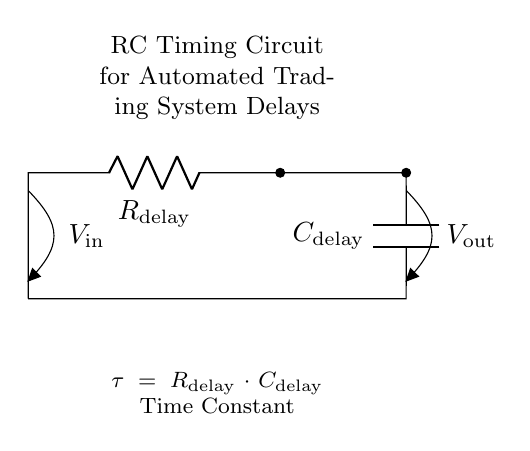What is the type of this circuit? The circuit is an RC timing circuit, as indicated by the presence of a resistor and a capacitor in series, used to create a specific time delay.
Answer: RC timing circuit What do R and C represent in this circuit? R represents the resistance value, specifically labeled as R delay, and C represents the capacitance value, specifically labeled as C delay.
Answer: R delay and C delay What is the formula for the time constant in this circuit? The time constant is given by the product of resistance and capacitance, expressed as tau equals R delay multiplied by C delay.
Answer: tau equals R delay multiplied by C delay What are the output and input voltages labeled as? The input voltage is labeled V in, and the output voltage is labeled V out. This shows the points where the voltages are measured in the circuit.
Answer: V in and V out How does increasing R delay affect the time constant? Increasing R delay increases the time constant, since tau is directly proportional to R delay, meaning the circuit will take longer to charge or discharge.
Answer: Increases time constant What happens to V out when the circuit reaches its time constant? At the time constant, V out will reach approximately 63.2% of V in, demonstrating how the capacitor charges over time in relation to the input voltage.
Answer: 63.2% of V in What is the significance of the time constant in an automated trading system? The time constant controls the delay in the system's response, influencing how quickly it reacts to market changes and potentially impacting trading decisions.
Answer: Influences system response delay 